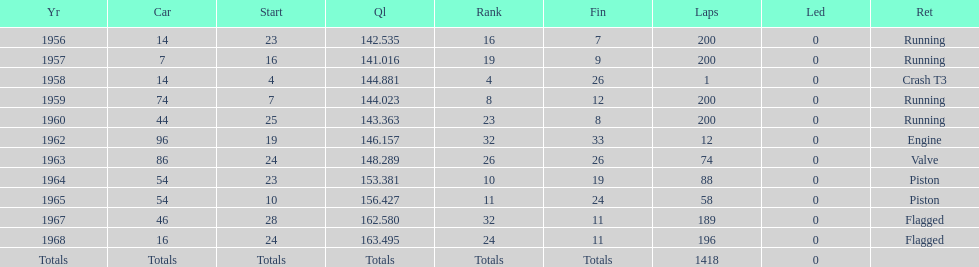What year did he have the same number car as 1964? 1965. 